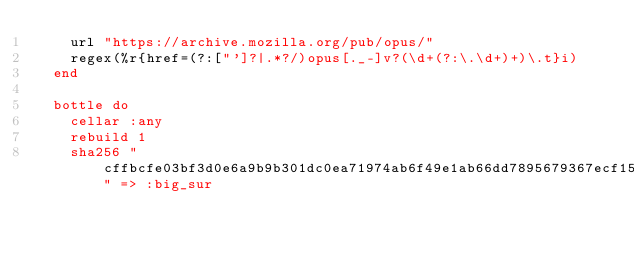Convert code to text. <code><loc_0><loc_0><loc_500><loc_500><_Ruby_>    url "https://archive.mozilla.org/pub/opus/"
    regex(%r{href=(?:["']?|.*?/)opus[._-]v?(\d+(?:\.\d+)+)\.t}i)
  end

  bottle do
    cellar :any
    rebuild 1
    sha256 "cffbcfe03bf3d0e6a9b9b301dc0ea71974ab6f49e1ab66dd7895679367ecf156" => :big_sur</code> 